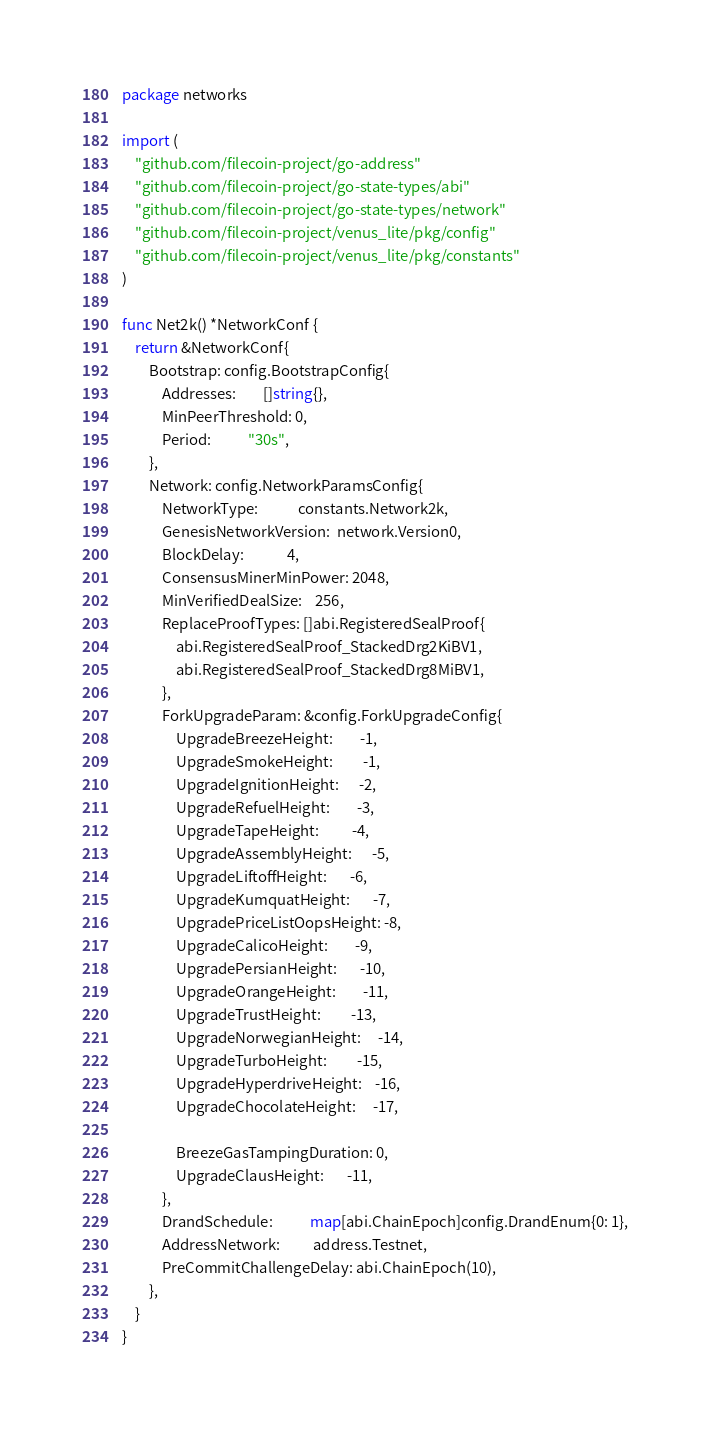<code> <loc_0><loc_0><loc_500><loc_500><_Go_>package networks

import (
	"github.com/filecoin-project/go-address"
	"github.com/filecoin-project/go-state-types/abi"
	"github.com/filecoin-project/go-state-types/network"
	"github.com/filecoin-project/venus_lite/pkg/config"
	"github.com/filecoin-project/venus_lite/pkg/constants"
)

func Net2k() *NetworkConf {
	return &NetworkConf{
		Bootstrap: config.BootstrapConfig{
			Addresses:        []string{},
			MinPeerThreshold: 0,
			Period:           "30s",
		},
		Network: config.NetworkParamsConfig{
			NetworkType:            constants.Network2k,
			GenesisNetworkVersion:  network.Version0,
			BlockDelay:             4,
			ConsensusMinerMinPower: 2048,
			MinVerifiedDealSize:    256,
			ReplaceProofTypes: []abi.RegisteredSealProof{
				abi.RegisteredSealProof_StackedDrg2KiBV1,
				abi.RegisteredSealProof_StackedDrg8MiBV1,
			},
			ForkUpgradeParam: &config.ForkUpgradeConfig{
				UpgradeBreezeHeight:        -1,
				UpgradeSmokeHeight:         -1,
				UpgradeIgnitionHeight:      -2,
				UpgradeRefuelHeight:        -3,
				UpgradeTapeHeight:          -4,
				UpgradeAssemblyHeight:      -5,
				UpgradeLiftoffHeight:       -6,
				UpgradeKumquatHeight:       -7,
				UpgradePriceListOopsHeight: -8,
				UpgradeCalicoHeight:        -9,
				UpgradePersianHeight:       -10,
				UpgradeOrangeHeight:        -11,
				UpgradeTrustHeight:         -13,
				UpgradeNorwegianHeight:     -14,
				UpgradeTurboHeight:         -15,
				UpgradeHyperdriveHeight:    -16,
				UpgradeChocolateHeight:     -17,

				BreezeGasTampingDuration: 0,
				UpgradeClausHeight:       -11,
			},
			DrandSchedule:           map[abi.ChainEpoch]config.DrandEnum{0: 1},
			AddressNetwork:          address.Testnet,
			PreCommitChallengeDelay: abi.ChainEpoch(10),
		},
	}
}
</code> 